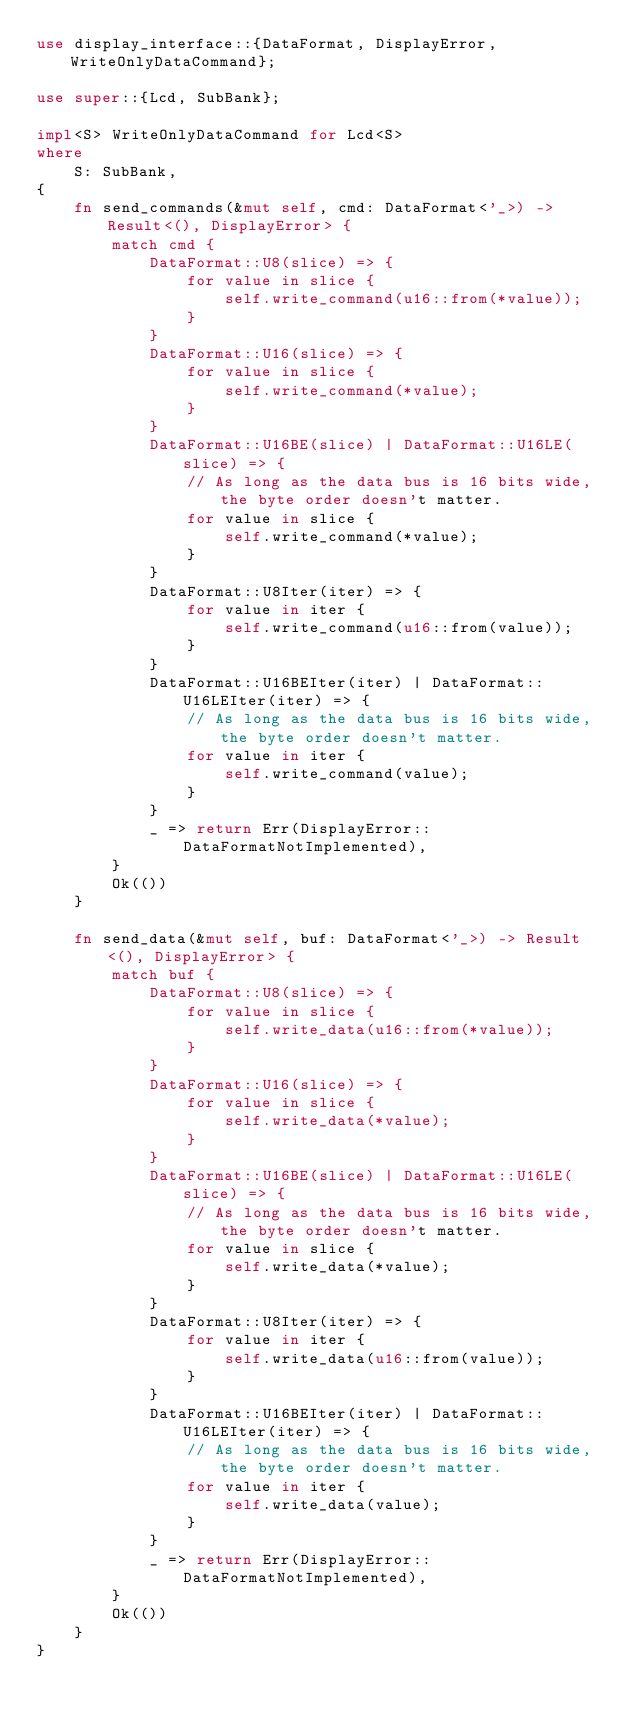Convert code to text. <code><loc_0><loc_0><loc_500><loc_500><_Rust_>use display_interface::{DataFormat, DisplayError, WriteOnlyDataCommand};

use super::{Lcd, SubBank};

impl<S> WriteOnlyDataCommand for Lcd<S>
where
    S: SubBank,
{
    fn send_commands(&mut self, cmd: DataFormat<'_>) -> Result<(), DisplayError> {
        match cmd {
            DataFormat::U8(slice) => {
                for value in slice {
                    self.write_command(u16::from(*value));
                }
            }
            DataFormat::U16(slice) => {
                for value in slice {
                    self.write_command(*value);
                }
            }
            DataFormat::U16BE(slice) | DataFormat::U16LE(slice) => {
                // As long as the data bus is 16 bits wide, the byte order doesn't matter.
                for value in slice {
                    self.write_command(*value);
                }
            }
            DataFormat::U8Iter(iter) => {
                for value in iter {
                    self.write_command(u16::from(value));
                }
            }
            DataFormat::U16BEIter(iter) | DataFormat::U16LEIter(iter) => {
                // As long as the data bus is 16 bits wide, the byte order doesn't matter.
                for value in iter {
                    self.write_command(value);
                }
            }
            _ => return Err(DisplayError::DataFormatNotImplemented),
        }
        Ok(())
    }

    fn send_data(&mut self, buf: DataFormat<'_>) -> Result<(), DisplayError> {
        match buf {
            DataFormat::U8(slice) => {
                for value in slice {
                    self.write_data(u16::from(*value));
                }
            }
            DataFormat::U16(slice) => {
                for value in slice {
                    self.write_data(*value);
                }
            }
            DataFormat::U16BE(slice) | DataFormat::U16LE(slice) => {
                // As long as the data bus is 16 bits wide, the byte order doesn't matter.
                for value in slice {
                    self.write_data(*value);
                }
            }
            DataFormat::U8Iter(iter) => {
                for value in iter {
                    self.write_data(u16::from(value));
                }
            }
            DataFormat::U16BEIter(iter) | DataFormat::U16LEIter(iter) => {
                // As long as the data bus is 16 bits wide, the byte order doesn't matter.
                for value in iter {
                    self.write_data(value);
                }
            }
            _ => return Err(DisplayError::DataFormatNotImplemented),
        }
        Ok(())
    }
}
</code> 